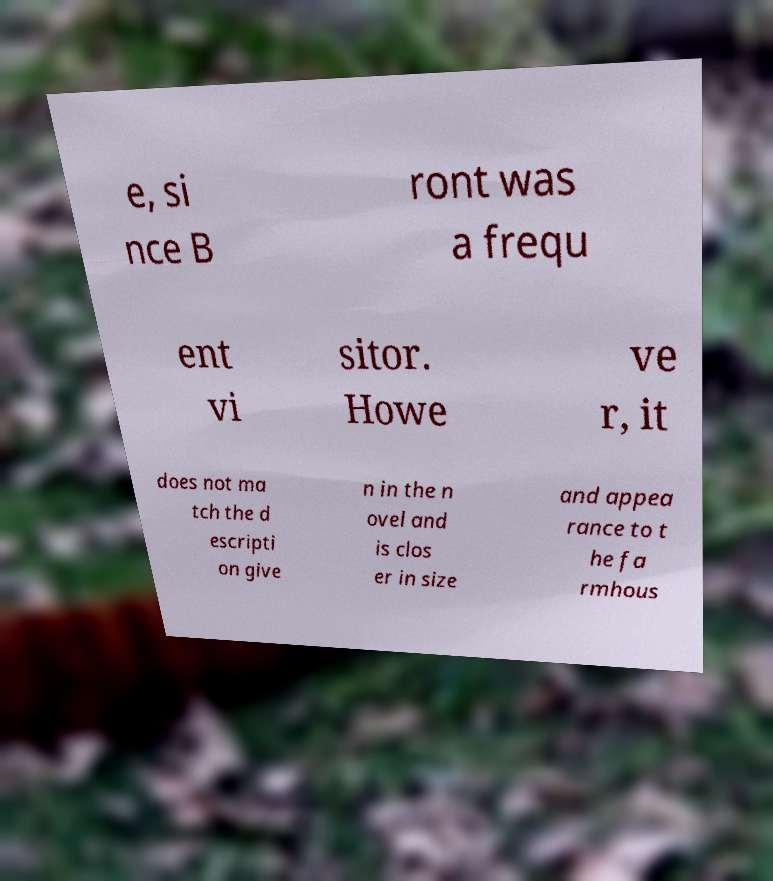Could you extract and type out the text from this image? e, si nce B ront was a frequ ent vi sitor. Howe ve r, it does not ma tch the d escripti on give n in the n ovel and is clos er in size and appea rance to t he fa rmhous 